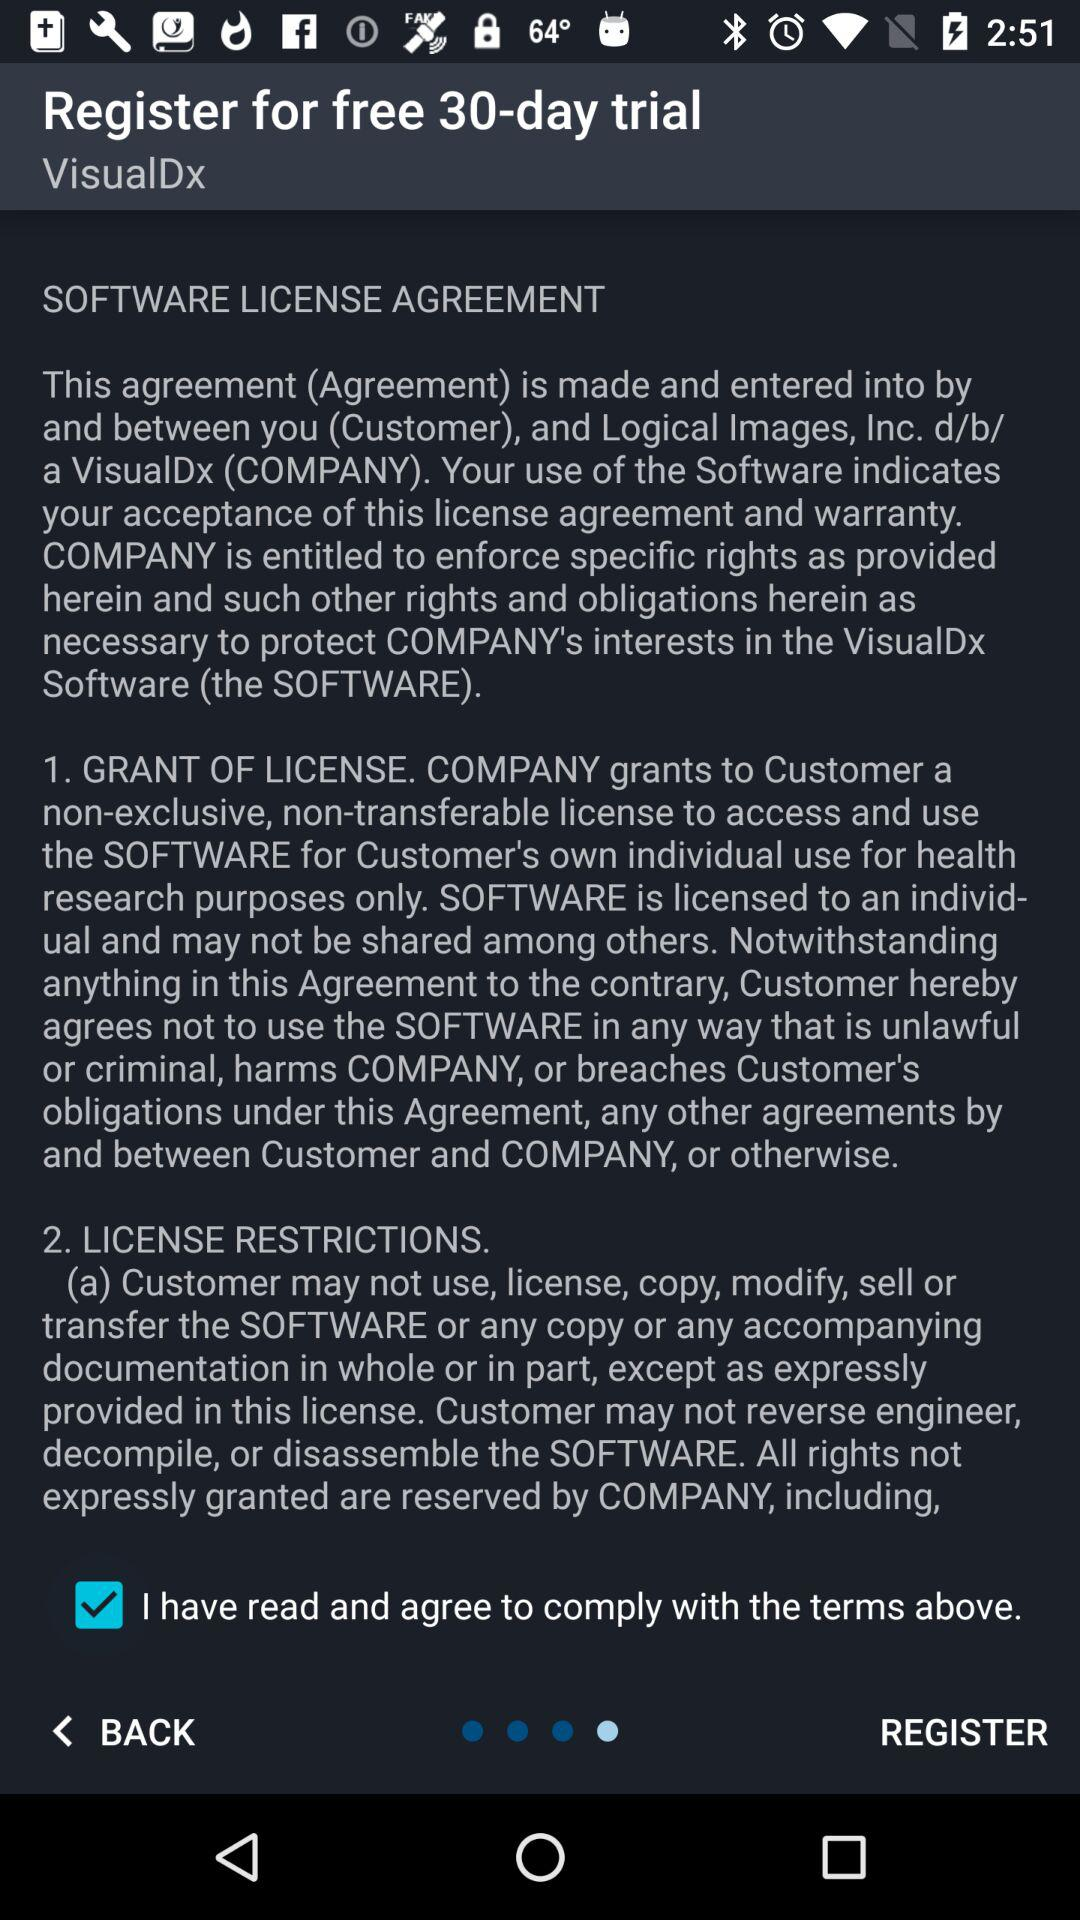What is the status of "I have read and agree to comply with the terms above"? The status is "on". 